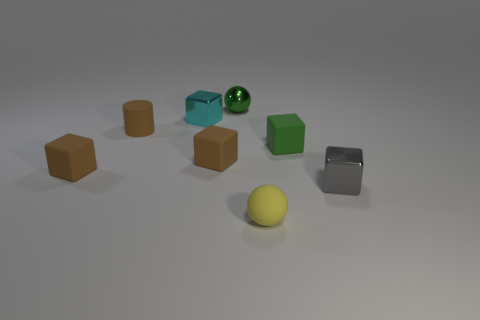Subtract all green rubber cubes. How many cubes are left? 4 Add 1 yellow balls. How many objects exist? 9 Subtract all gray cylinders. How many brown blocks are left? 2 Subtract all cubes. How many objects are left? 3 Subtract 2 blocks. How many blocks are left? 3 Subtract all green blocks. How many blocks are left? 4 Subtract all red cylinders. Subtract all green balls. How many cylinders are left? 1 Subtract all tiny green matte cubes. Subtract all tiny rubber cubes. How many objects are left? 4 Add 6 brown cylinders. How many brown cylinders are left? 7 Add 3 tiny gray blocks. How many tiny gray blocks exist? 4 